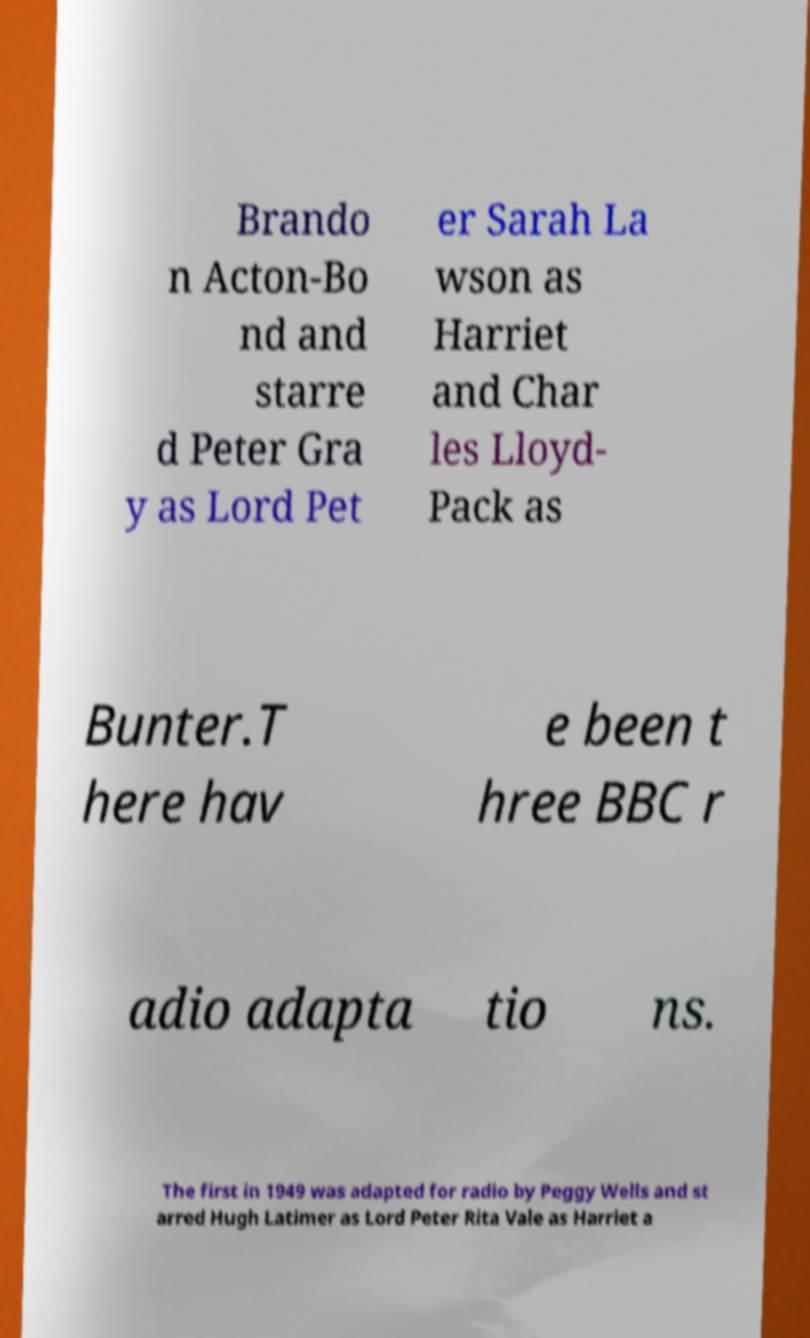What messages or text are displayed in this image? I need them in a readable, typed format. Brando n Acton-Bo nd and starre d Peter Gra y as Lord Pet er Sarah La wson as Harriet and Char les Lloyd- Pack as Bunter.T here hav e been t hree BBC r adio adapta tio ns. The first in 1949 was adapted for radio by Peggy Wells and st arred Hugh Latimer as Lord Peter Rita Vale as Harriet a 